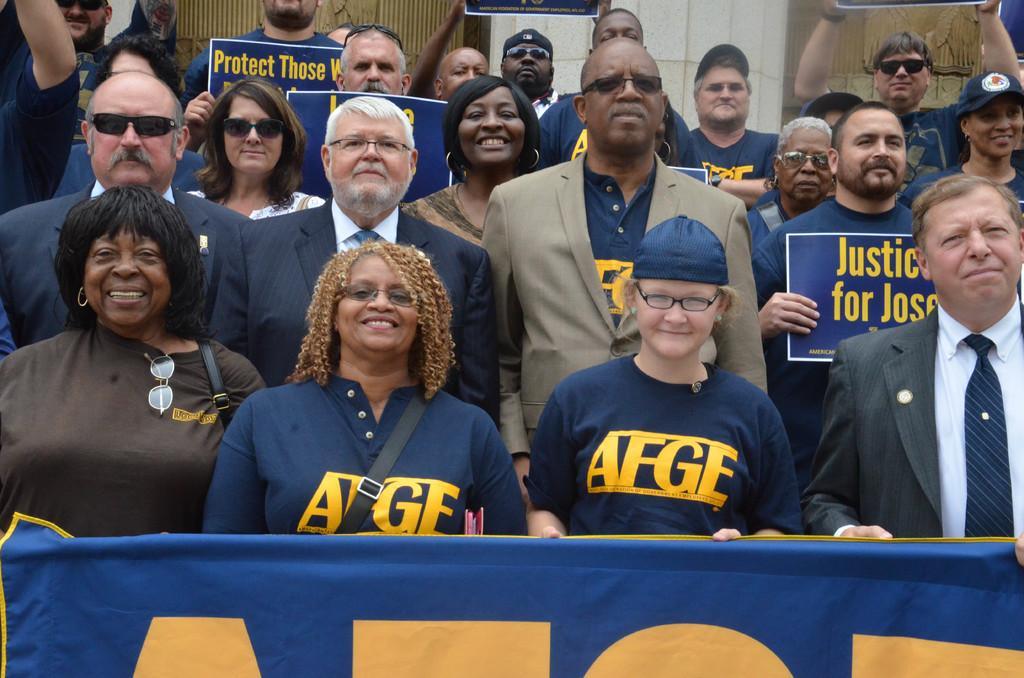Describe this image in one or two sentences. In this image we can see a group of people wearing dress. Some persons are wearing spectacles and goggles, some persons are holding boards with some text. In the foreground we can see a banner with some text and in the background, we can see a building with pillar and some sculptures. 